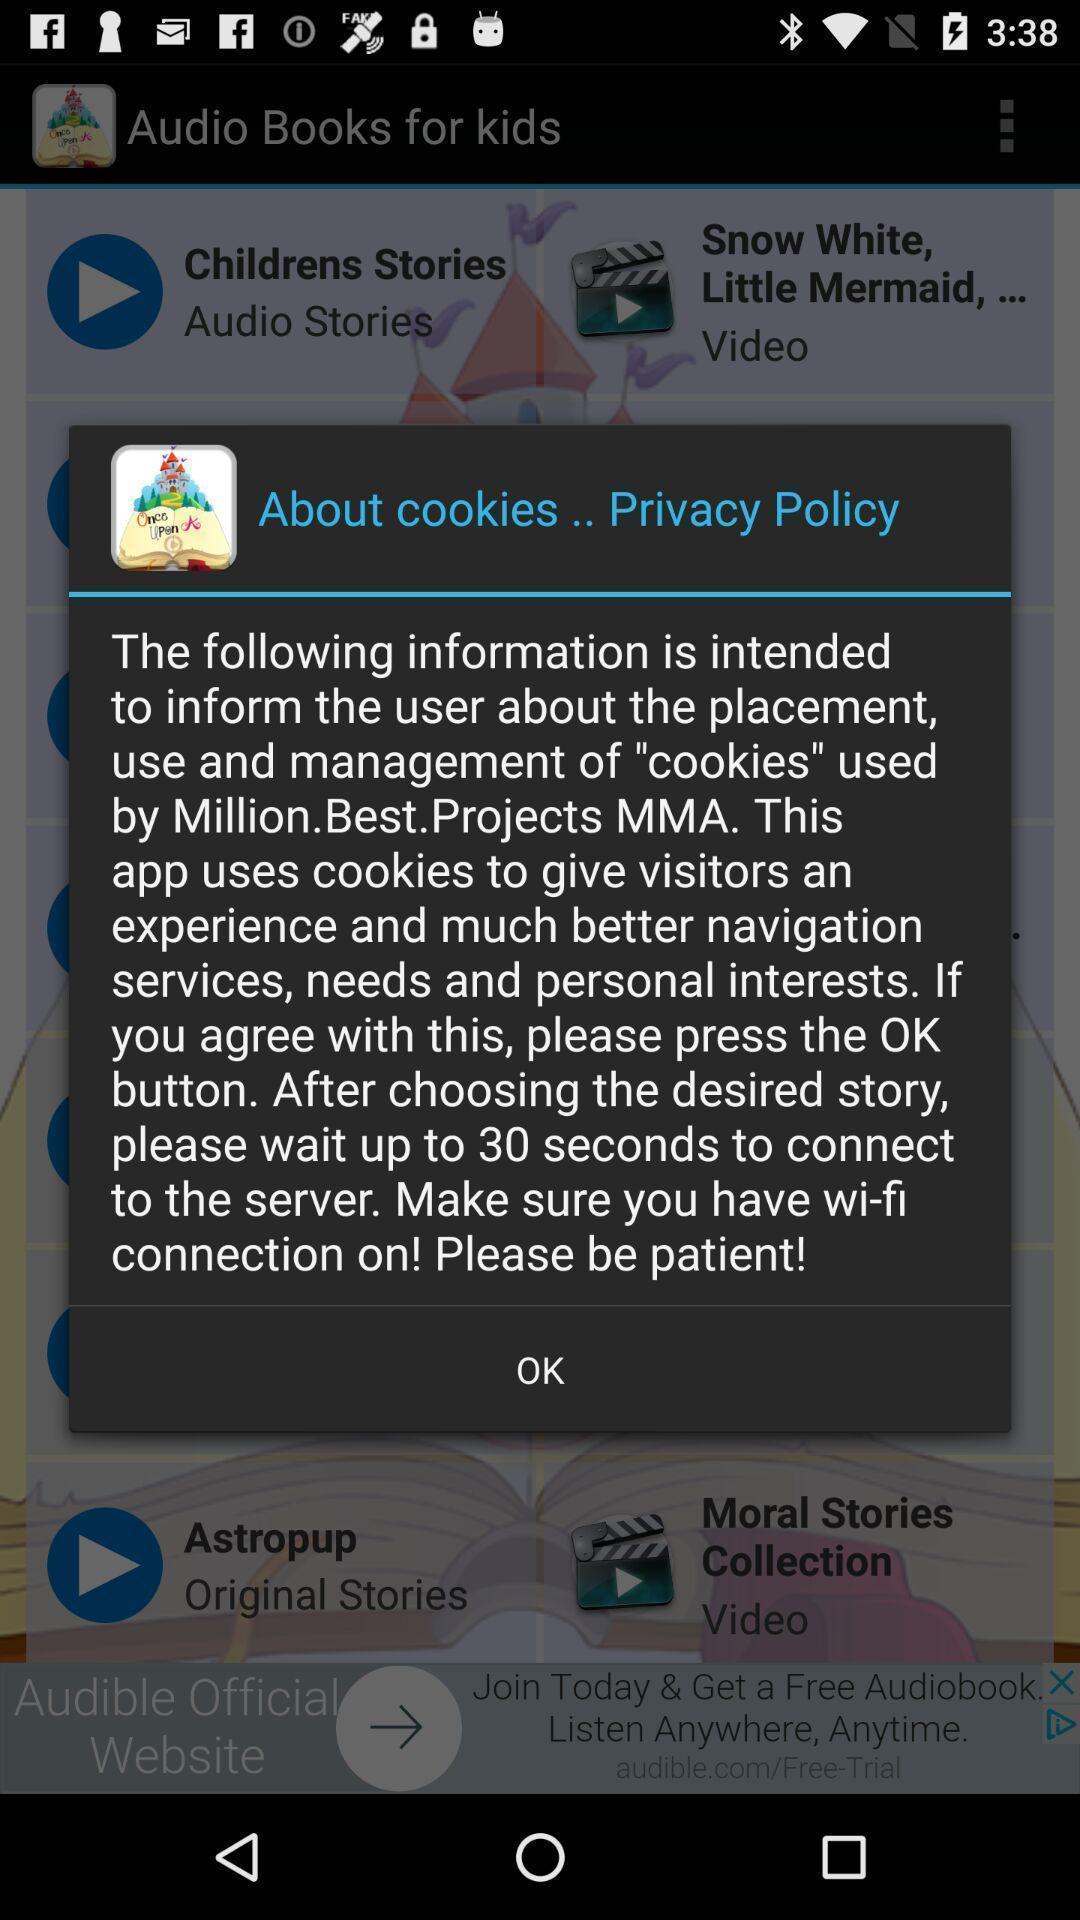Tell me about the visual elements in this screen capture. Popup displaying privacy policy. 